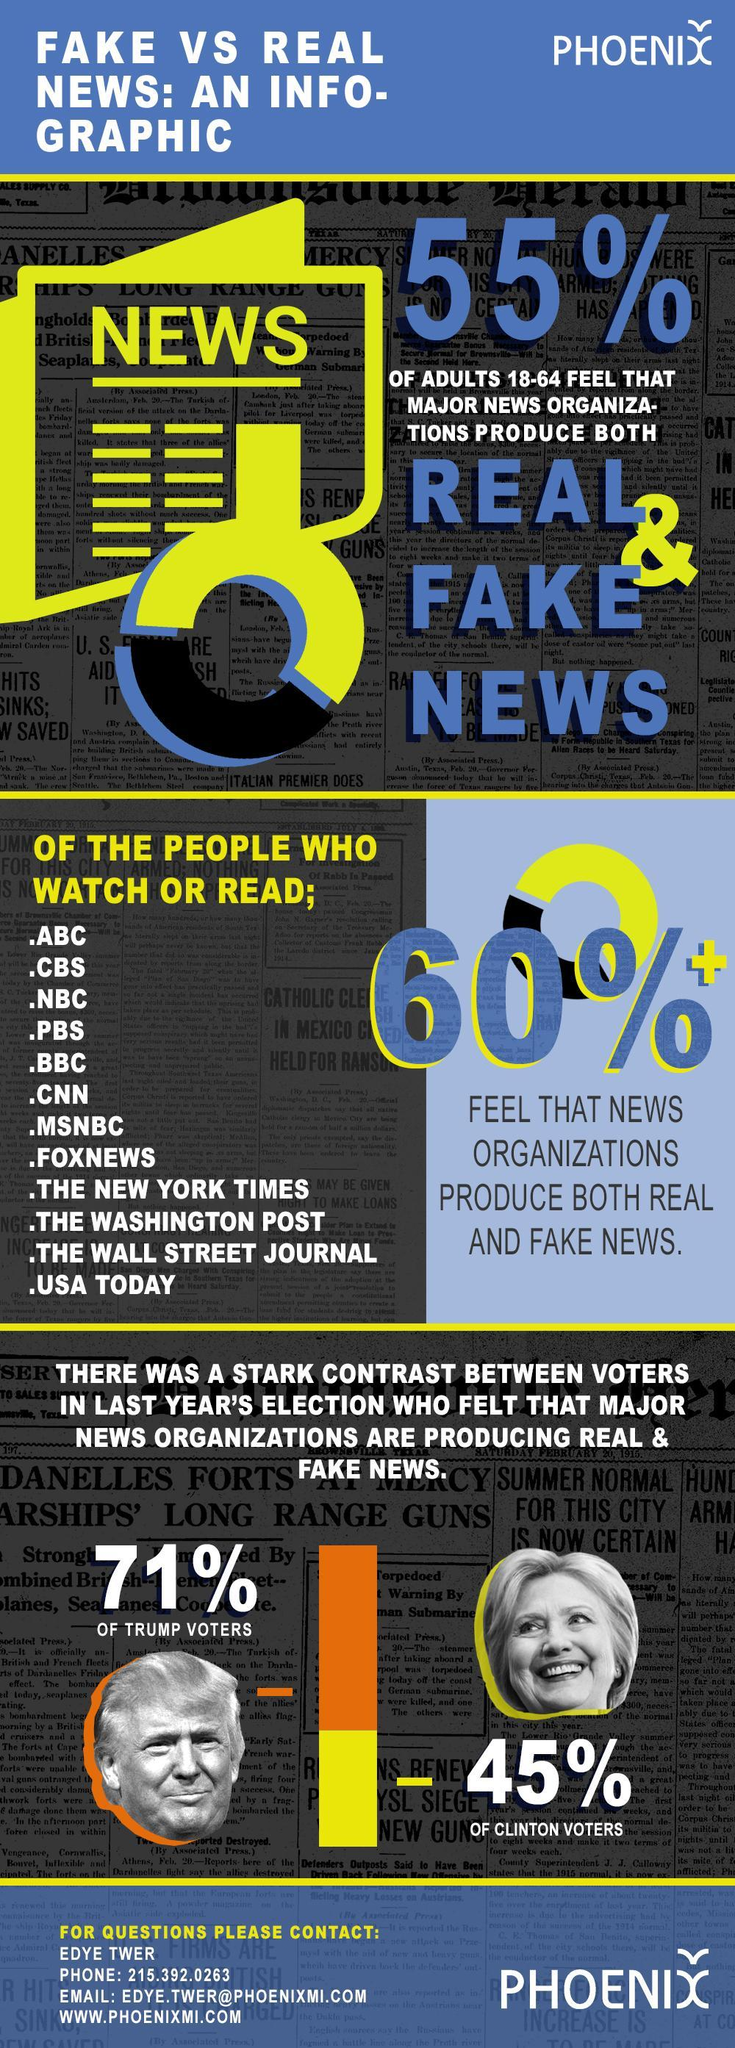What percentage of adults feel that the major news organisations produce both real and fake news?
Answer the question with a short phrase. 55% What percentage of Clinton voters felt that news organisations are producing real and fake news? 45% Name the first 3 news organisations mentioned? ABC, CBS, NBC What percentage of Trump voters agreed that news organisations are producing real and fake news? 71% 